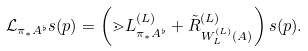Convert formula to latex. <formula><loc_0><loc_0><loc_500><loc_500>\mathcal { L } _ { \pi _ { * } A ^ { \flat } } s ( p ) = \left ( \mathbb { m } { L } ^ { ( L ) } _ { \pi _ { * } A ^ { \flat } } + \tilde { R } ^ { ( L ) } _ { W ^ { ( L ) } _ { L } ( A ) } \right ) s ( p ) .</formula> 